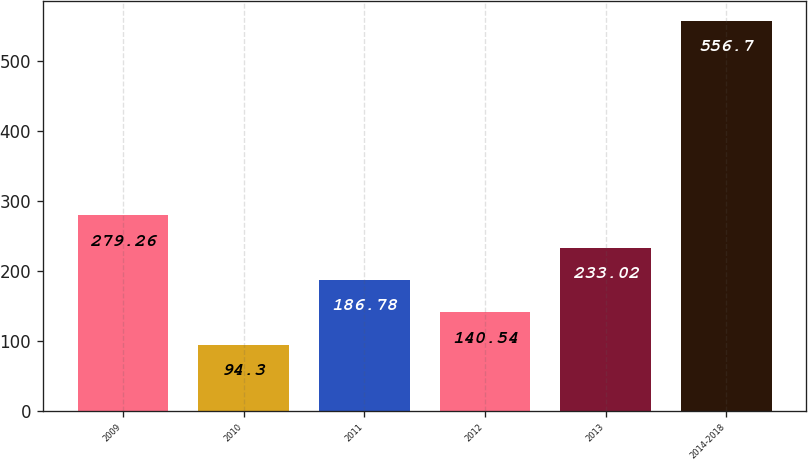Convert chart to OTSL. <chart><loc_0><loc_0><loc_500><loc_500><bar_chart><fcel>2009<fcel>2010<fcel>2011<fcel>2012<fcel>2013<fcel>2014-2018<nl><fcel>279.26<fcel>94.3<fcel>186.78<fcel>140.54<fcel>233.02<fcel>556.7<nl></chart> 